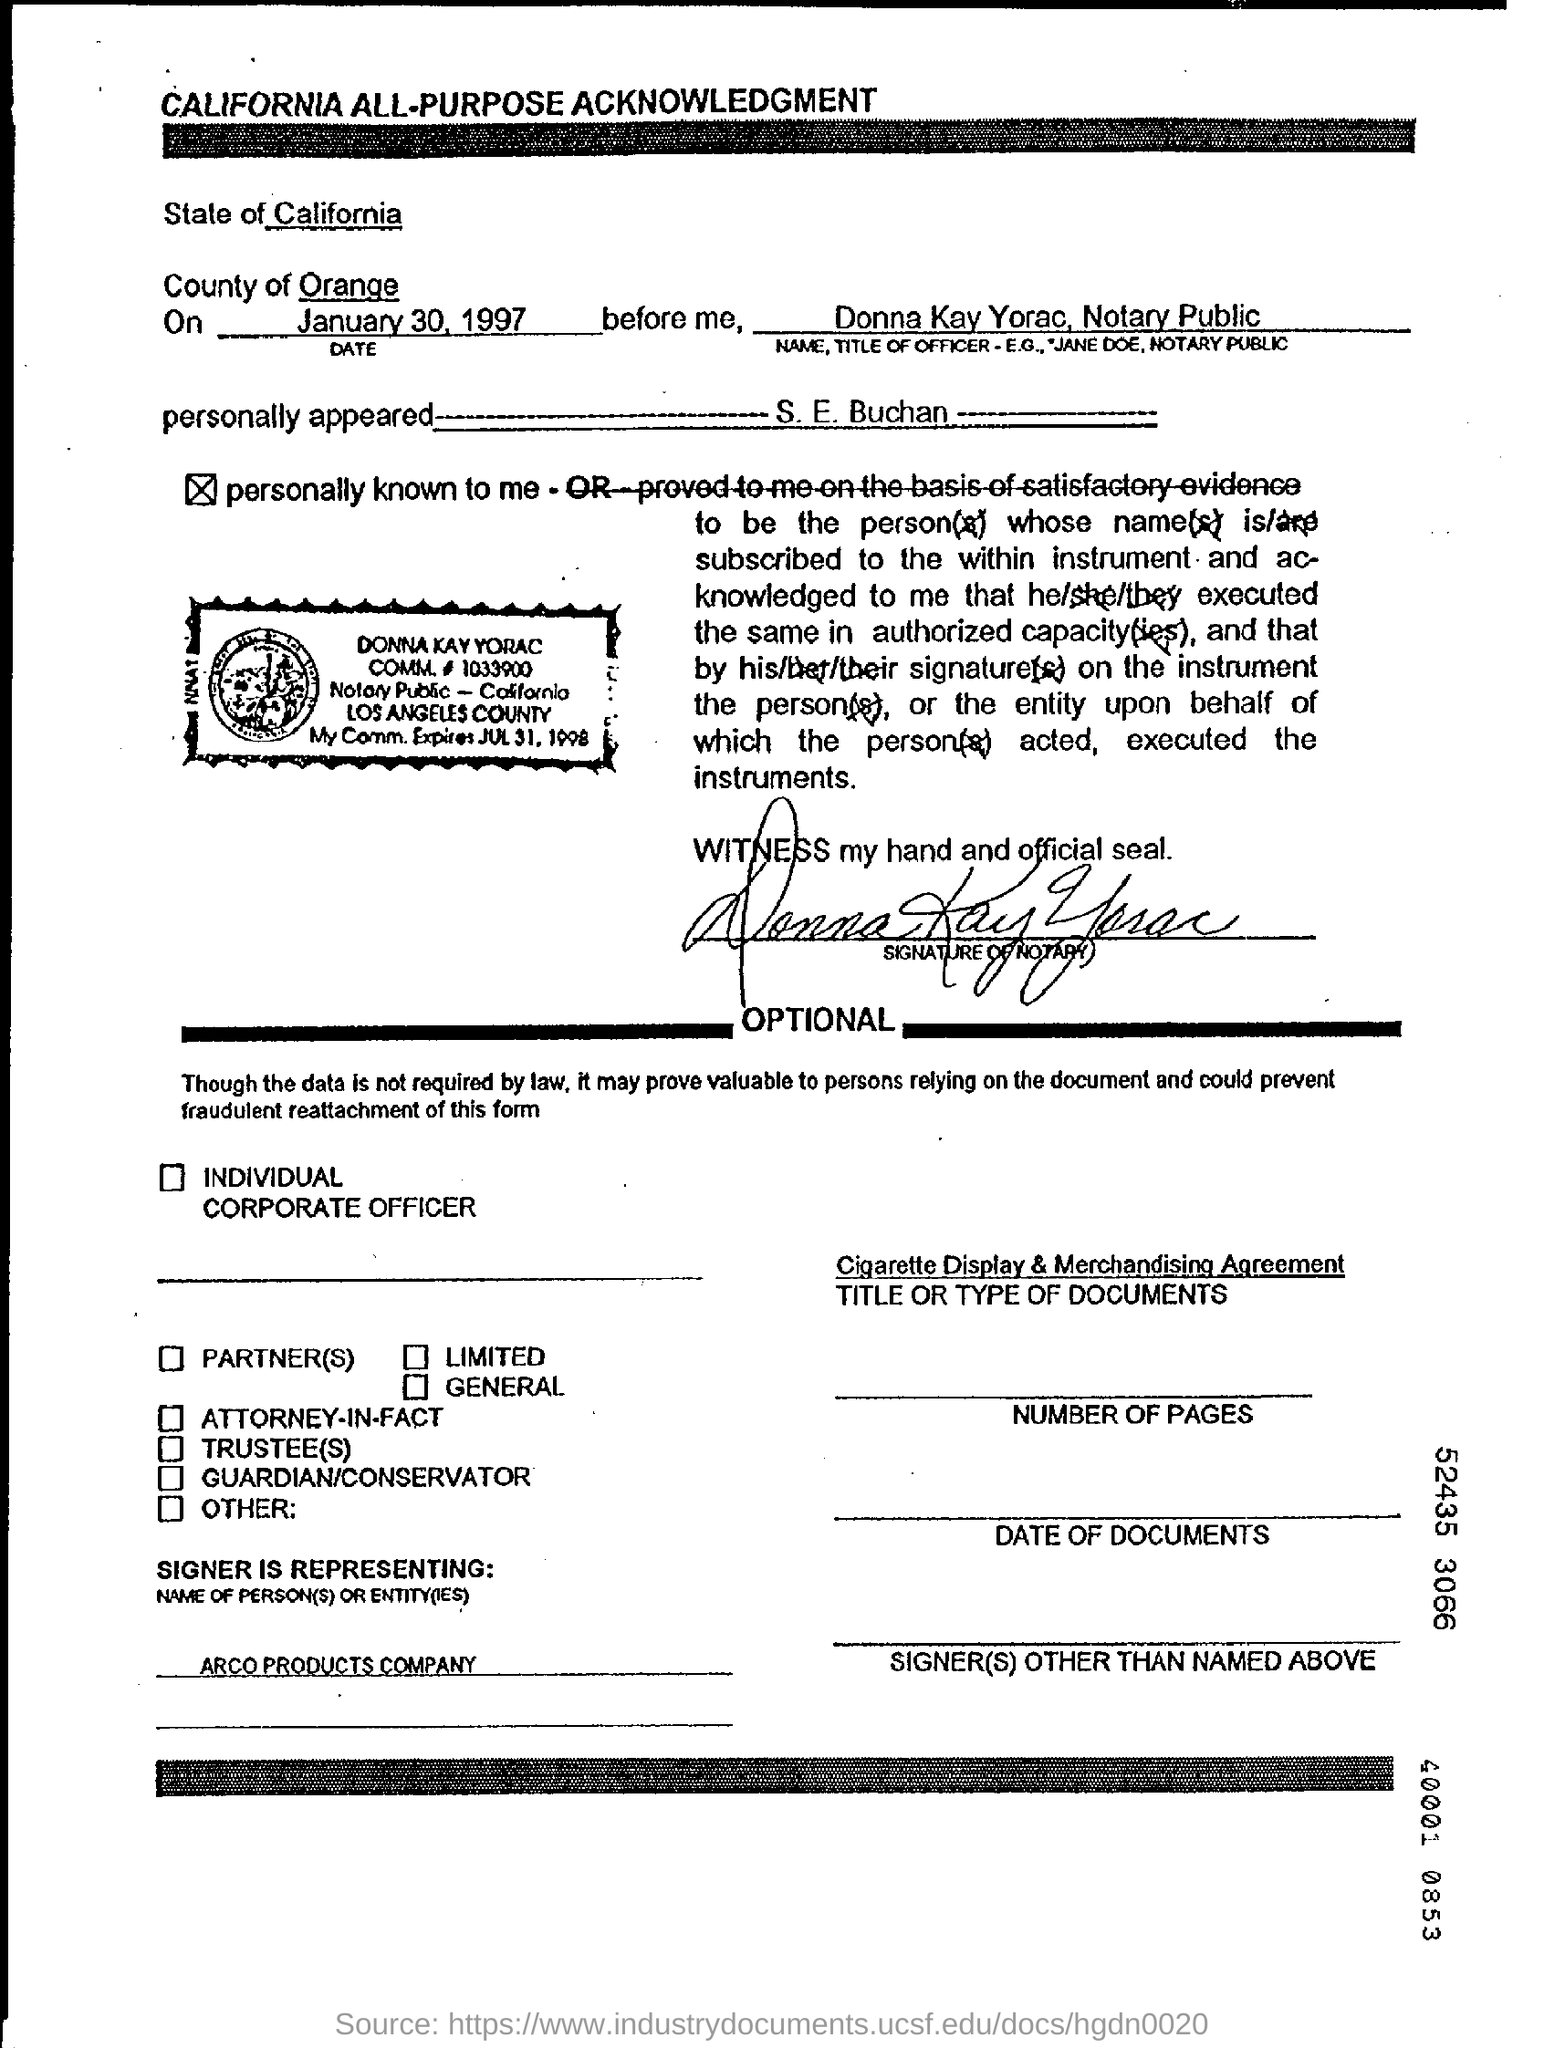Draw attention to some important aspects in this diagram. The name of the officer is Donna Kay Yorac. The title of the officer is notary public. The state mentioned is California. 